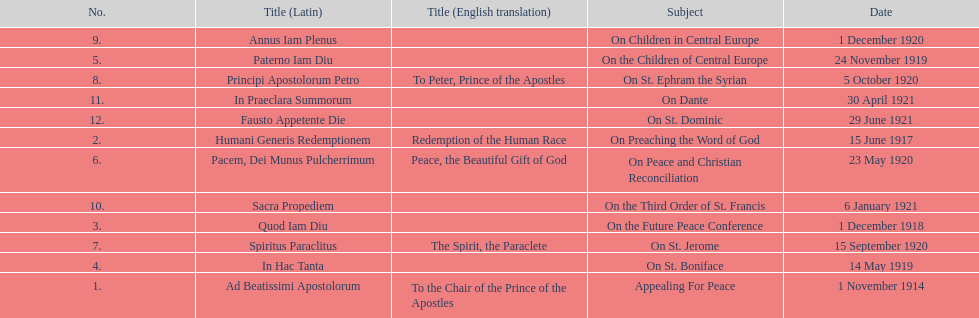After 1 december 1918 when was the next encyclical? 14 May 1919. 